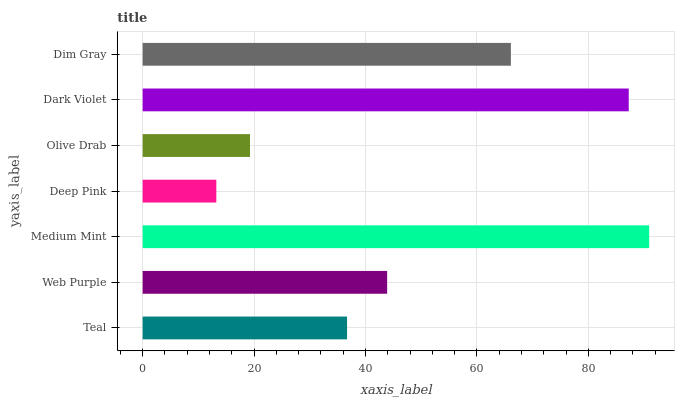Is Deep Pink the minimum?
Answer yes or no. Yes. Is Medium Mint the maximum?
Answer yes or no. Yes. Is Web Purple the minimum?
Answer yes or no. No. Is Web Purple the maximum?
Answer yes or no. No. Is Web Purple greater than Teal?
Answer yes or no. Yes. Is Teal less than Web Purple?
Answer yes or no. Yes. Is Teal greater than Web Purple?
Answer yes or no. No. Is Web Purple less than Teal?
Answer yes or no. No. Is Web Purple the high median?
Answer yes or no. Yes. Is Web Purple the low median?
Answer yes or no. Yes. Is Olive Drab the high median?
Answer yes or no. No. Is Teal the low median?
Answer yes or no. No. 